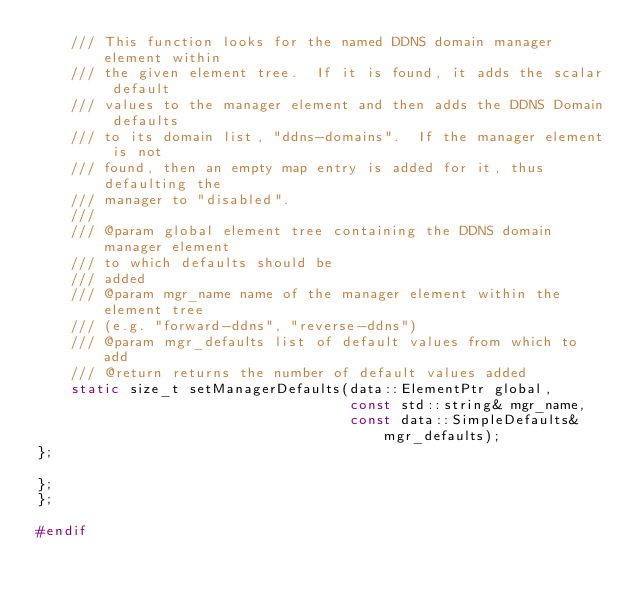Convert code to text. <code><loc_0><loc_0><loc_500><loc_500><_C_>    /// This function looks for the named DDNS domain manager element within
    /// the given element tree.  If it is found, it adds the scalar default
    /// values to the manager element and then adds the DDNS Domain defaults
    /// to its domain list, "ddns-domains".  If the manager element is not
    /// found, then an empty map entry is added for it, thus defaulting the
    /// manager to "disabled".
    ///
    /// @param global element tree containing the DDNS domain manager element
    /// to which defaults should be
    /// added
    /// @param mgr_name name of the manager element within the element tree
    /// (e.g. "forward-ddns", "reverse-ddns")
    /// @param mgr_defaults list of default values from which to add
    /// @return returns the number of default values added
    static size_t setManagerDefaults(data::ElementPtr global,
                                     const std::string& mgr_name,
                                     const data::SimpleDefaults& mgr_defaults);
};

};
};

#endif
</code> 